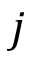Convert formula to latex. <formula><loc_0><loc_0><loc_500><loc_500>j</formula> 